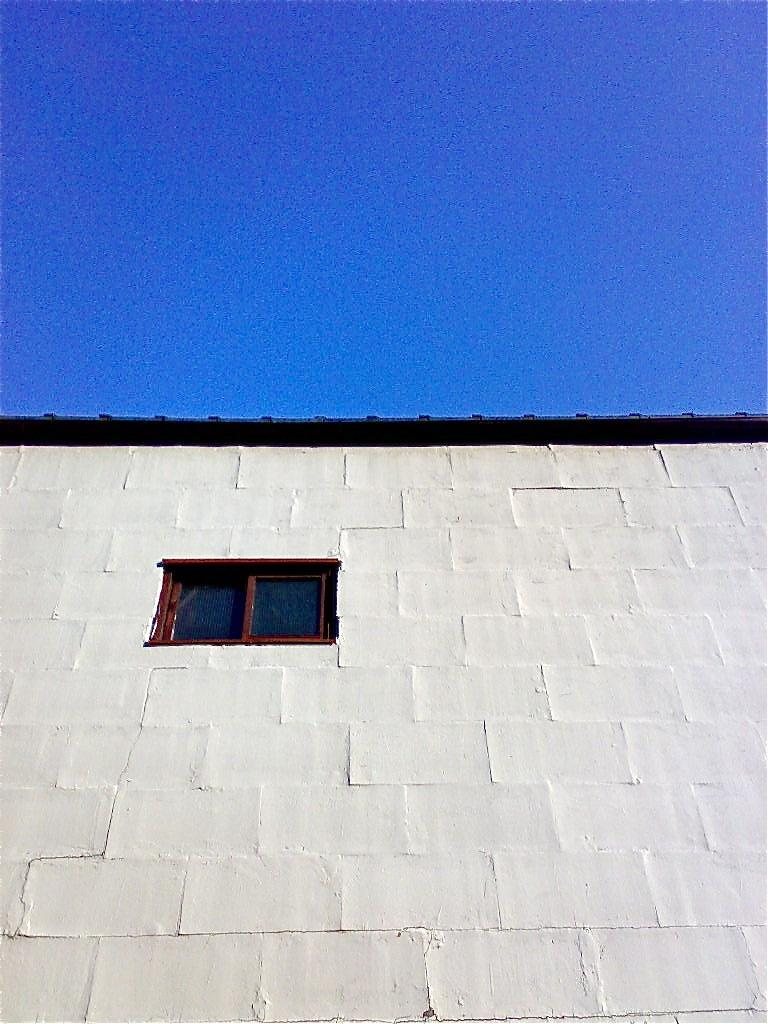What type of structure is visible in the image? There is a wall with a window in the image. What can be seen through the window? The sky is visible in the image. What type of cake is being served at the fictional event happening near the border in the image? There is no event or cake present in the image; it only features a wall with a window and the sky. 